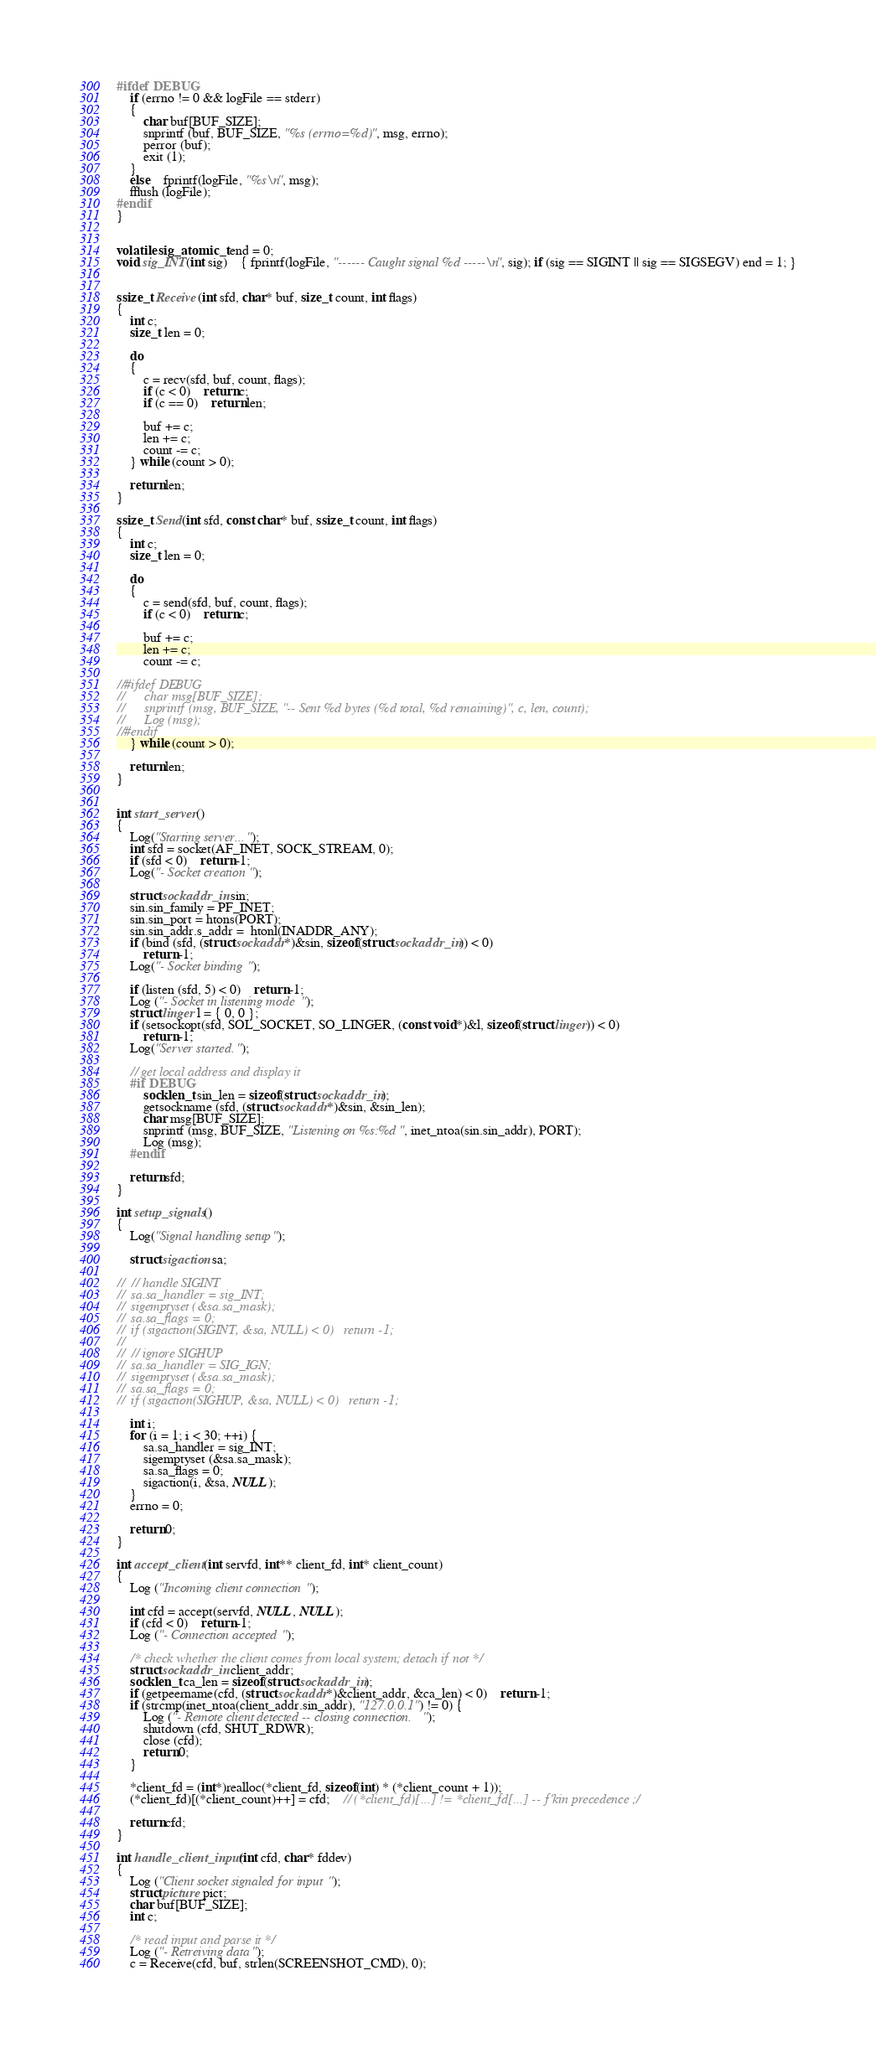Convert code to text. <code><loc_0><loc_0><loc_500><loc_500><_C_>#ifdef DEBUG
	if (errno != 0 && logFile == stderr)
	{
		char buf[BUF_SIZE];
		snprintf (buf, BUF_SIZE, "%s (errno=%d)", msg, errno);
		perror (buf);
		exit (1);
	}
	else	fprintf(logFile, "%s\n", msg);
	fflush (logFile);
#endif
}


volatile sig_atomic_t end = 0;
void sig_INT(int sig)	{ fprintf(logFile, "------ Caught signal %d -----\n", sig); if (sig == SIGINT || sig == SIGSEGV) end = 1; }


ssize_t Receive(int sfd, char* buf, size_t count, int flags)
{
	int c;
	size_t len = 0;

	do
	{
		c = recv(sfd, buf, count, flags);
		if (c < 0)	return c;
		if (c == 0)	return len;

		buf += c;
		len += c;
		count -= c;
	} while (count > 0);

	return len;
}

ssize_t Send(int sfd, const char* buf, ssize_t count, int flags)
{
	int c;
	size_t len = 0;

	do
	{
		c = send(sfd, buf, count, flags);
		if (c < 0)	return c;

		buf += c;
		len += c;
		count -= c;

//#ifdef DEBUG
//		char msg[BUF_SIZE];
//		snprintf (msg, BUF_SIZE, "-- Sent %d bytes (%d total, %d remaining)", c, len, count);
//		Log (msg);
//#endif
	} while (count > 0);

	return len;
}


int start_server()
{
	Log("Starting server...");
	int sfd = socket(AF_INET, SOCK_STREAM, 0);
	if (sfd < 0)	return -1;
	Log("- Socket creation");
	
	struct sockaddr_in sin;
	sin.sin_family = PF_INET;
	sin.sin_port = htons(PORT);
	sin.sin_addr.s_addr =  htonl(INADDR_ANY);
	if (bind (sfd, (struct sockaddr*)&sin, sizeof(struct sockaddr_in)) < 0)
		return -1;
	Log("- Socket binding");

	if (listen (sfd, 5) < 0)	return -1;
	Log ("- Socket in listening mode");
	struct linger l = { 0, 0 };
	if (setsockopt(sfd, SOL_SOCKET, SO_LINGER, (const void*)&l, sizeof(struct linger)) < 0)
		return -1;
	Log("Server started.");

	// get local address and display it
	#if DEBUG
		socklen_t sin_len = sizeof(struct sockaddr_in);
		getsockname (sfd, (struct sockaddr*)&sin, &sin_len);
		char msg[BUF_SIZE];
		snprintf (msg, BUF_SIZE, "Listening on %s:%d", inet_ntoa(sin.sin_addr), PORT);
		Log (msg);
	#endif

	return sfd;
}

int setup_signals()
{
	Log("Signal handling setup");

	struct sigaction sa;

//	// handle SIGINT
//	sa.sa_handler = sig_INT;
//	sigemptyset (&sa.sa_mask);
//	sa.sa_flags = 0;
//	if (sigaction(SIGINT, &sa, NULL) < 0)	return -1;
//
//	// ignore SIGHUP
//	sa.sa_handler = SIG_IGN;
//	sigemptyset (&sa.sa_mask);
//	sa.sa_flags = 0;
//	if (sigaction(SIGHUP, &sa, NULL) < 0)	return -1;

	int i;
	for (i = 1; i < 30; ++i) {
		sa.sa_handler = sig_INT;
		sigemptyset (&sa.sa_mask);
		sa.sa_flags = 0;
		sigaction(i, &sa, NULL);
	}
	errno = 0;

	return 0;
}

int accept_client(int servfd, int** client_fd, int* client_count)
{
	Log ("Incoming client connection");

	int cfd = accept(servfd, NULL, NULL);
	if (cfd < 0)	return -1;
	Log ("- Connection accepted");

	/* check whether the client comes from local system; detach if not */
	struct sockaddr_in client_addr;
	socklen_t ca_len = sizeof(struct sockaddr_in);
	if (getpeername(cfd, (struct sockaddr*)&client_addr, &ca_len) < 0)	return -1;
	if (strcmp(inet_ntoa(client_addr.sin_addr), "127.0.0.1") != 0) {
		Log ("- Remote client detected -- closing connection.");
		shutdown (cfd, SHUT_RDWR);
		close (cfd);
		return 0;
	}

	*client_fd = (int*)realloc(*client_fd, sizeof(int) * (*client_count + 1));
	(*client_fd)[(*client_count)++] = cfd;	// (*client_fd)[...] != *client_fd[...] -- f'kin precedence ;/

	return cfd;
}

int handle_client_input(int cfd, char* fddev)
{
	Log ("Client socket signaled for input");
	struct picture pict;
	char buf[BUF_SIZE];
	int c;	
	
	/* read input and parse it */
	Log ("- Retreiving data");
	c = Receive(cfd, buf, strlen(SCREENSHOT_CMD), 0);</code> 